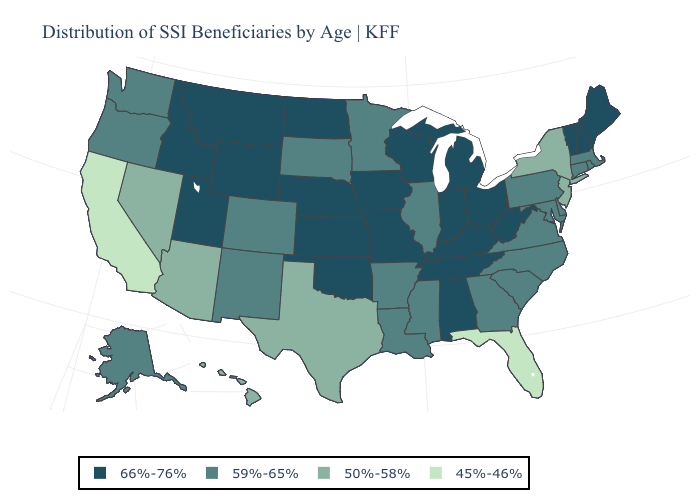What is the value of Maine?
Write a very short answer. 66%-76%. What is the value of Iowa?
Keep it brief. 66%-76%. What is the lowest value in states that border New Jersey?
Answer briefly. 50%-58%. Name the states that have a value in the range 45%-46%?
Short answer required. California, Florida. What is the value of Arizona?
Quick response, please. 50%-58%. Among the states that border Colorado , does Kansas have the highest value?
Write a very short answer. Yes. Does the map have missing data?
Give a very brief answer. No. Name the states that have a value in the range 45%-46%?
Write a very short answer. California, Florida. What is the value of Oklahoma?
Be succinct. 66%-76%. What is the value of West Virginia?
Give a very brief answer. 66%-76%. Does Indiana have the same value as Montana?
Quick response, please. Yes. What is the lowest value in states that border Kansas?
Give a very brief answer. 59%-65%. Name the states that have a value in the range 59%-65%?
Be succinct. Alaska, Arkansas, Colorado, Connecticut, Delaware, Georgia, Illinois, Louisiana, Maryland, Massachusetts, Minnesota, Mississippi, New Mexico, North Carolina, Oregon, Pennsylvania, Rhode Island, South Carolina, South Dakota, Virginia, Washington. What is the value of Connecticut?
Quick response, please. 59%-65%. What is the value of West Virginia?
Give a very brief answer. 66%-76%. 